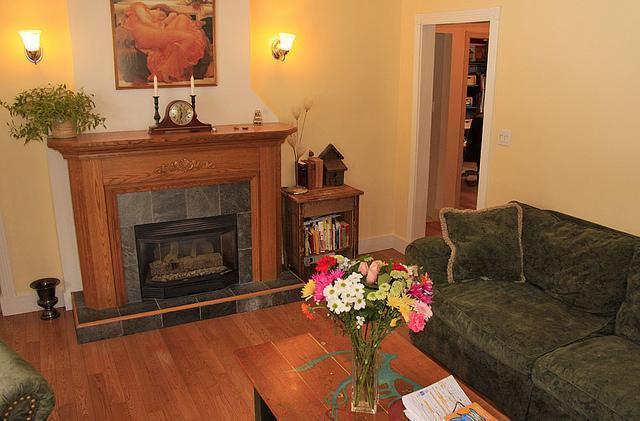How many portraits are hung above the fireplace mantle?
Choose the right answer and clarify with the format: 'Answer: answer
Rationale: rationale.'
Options: Three, four, one, two. Answer: one.
Rationale: And it might not be a true portrait. it may be an artist's dream. 